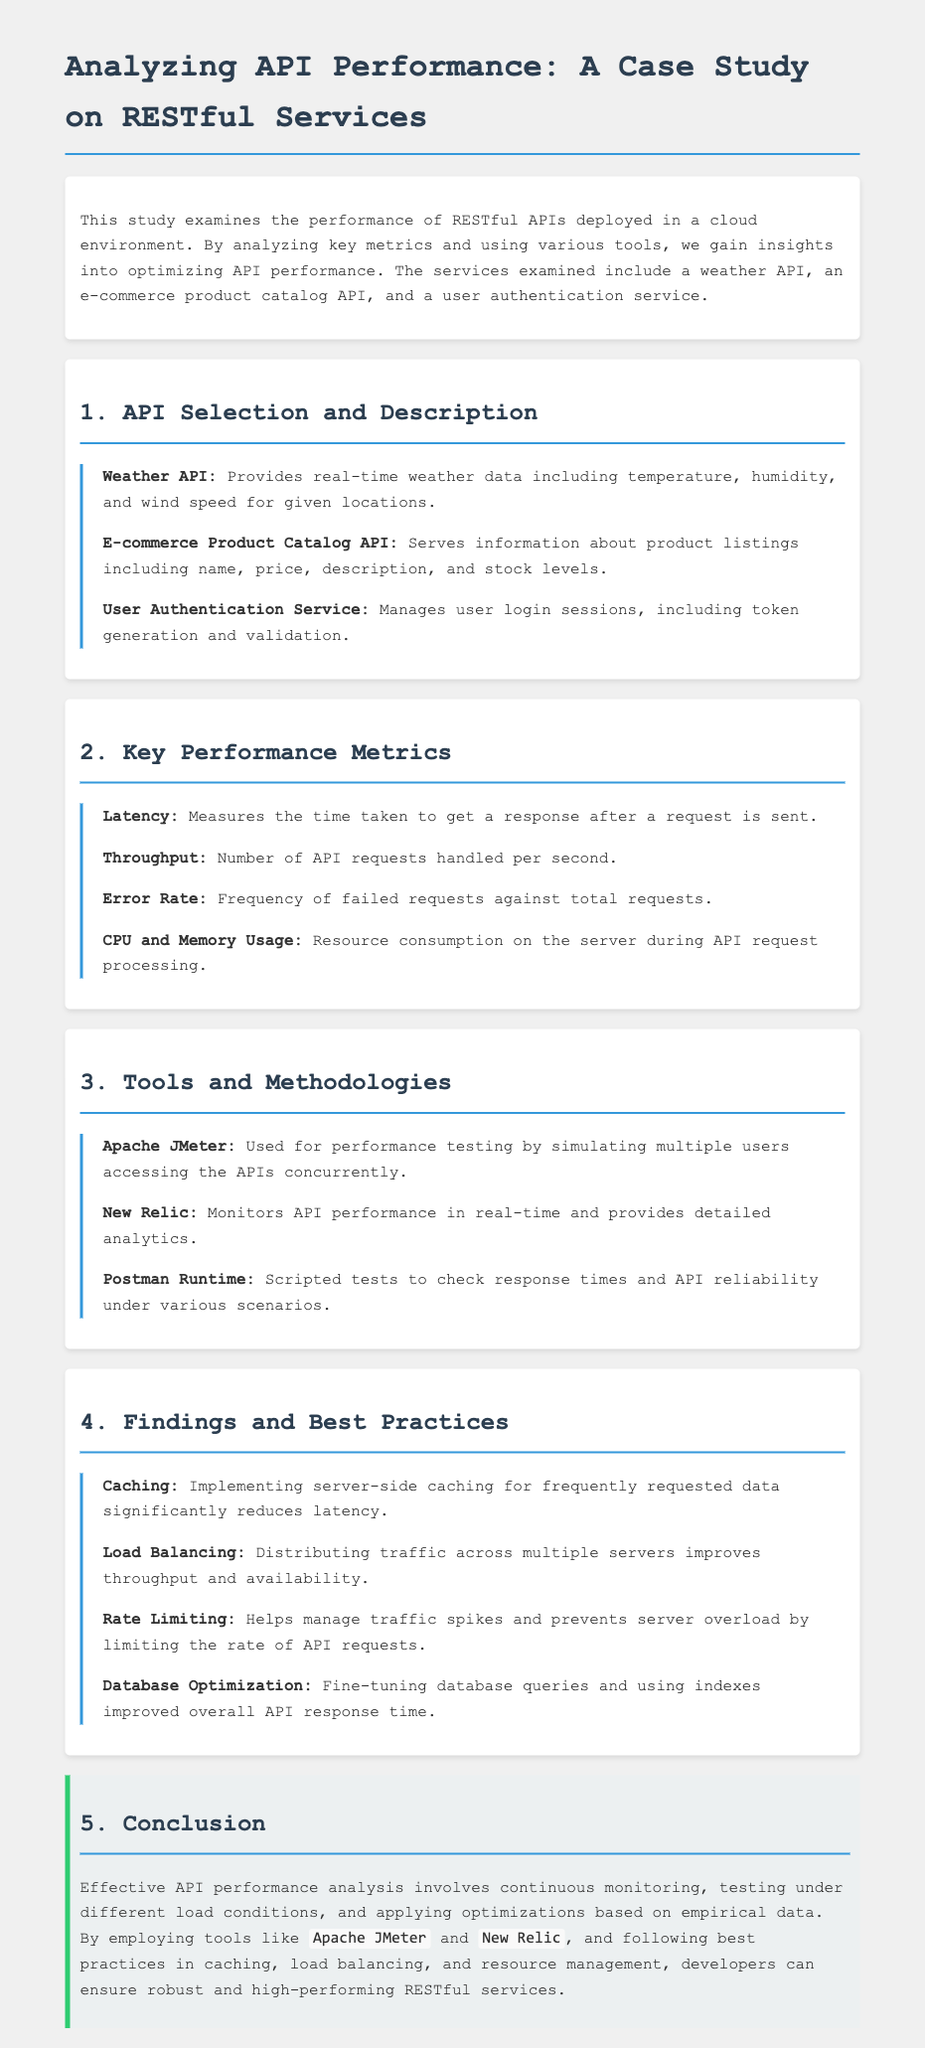What is the title of the homework? The title of the homework is the main heading of the document, which is given as "Analyzing API Performance: A Case Study on RESTful Services."
Answer: Analyzing API Performance: A Case Study on RESTful Services What does the Weather API provide? The Weather API provides real-time weather data including temperature, humidity, and wind speed for given locations.
Answer: Real-time weather data What tool is used for performance testing? The tool used for performance testing by simulating multiple users accessing the APIs concurrently is mentioned in the section on tools and methodologies.
Answer: Apache JMeter What is measured by the term "Latency"? Latency measures the time taken to get a response after a request is sent.
Answer: Time taken to get a response How many key performance metrics are listed in the document? The document lists four key performance metrics in the section titled "Key Performance Metrics."
Answer: Four Which practice is recommended for reducing latency? The recommended practice to reduce latency involves implementing server-side caching for frequently requested data.
Answer: Caching What service manages user login sessions? The service that manages user login sessions, including token generation and validation, is described under API Selection.
Answer: User Authentication Service What is the main conclusion of the document? The main conclusion emphasizes the importance of continuous monitoring, testing, and applying optimizations based on empirical data.
Answer: Continuous monitoring and testing What does "Throughput" refer to? Throughput refers to the number of API requests handled per second, as defined under key performance metrics.
Answer: Number of API requests handled per second 